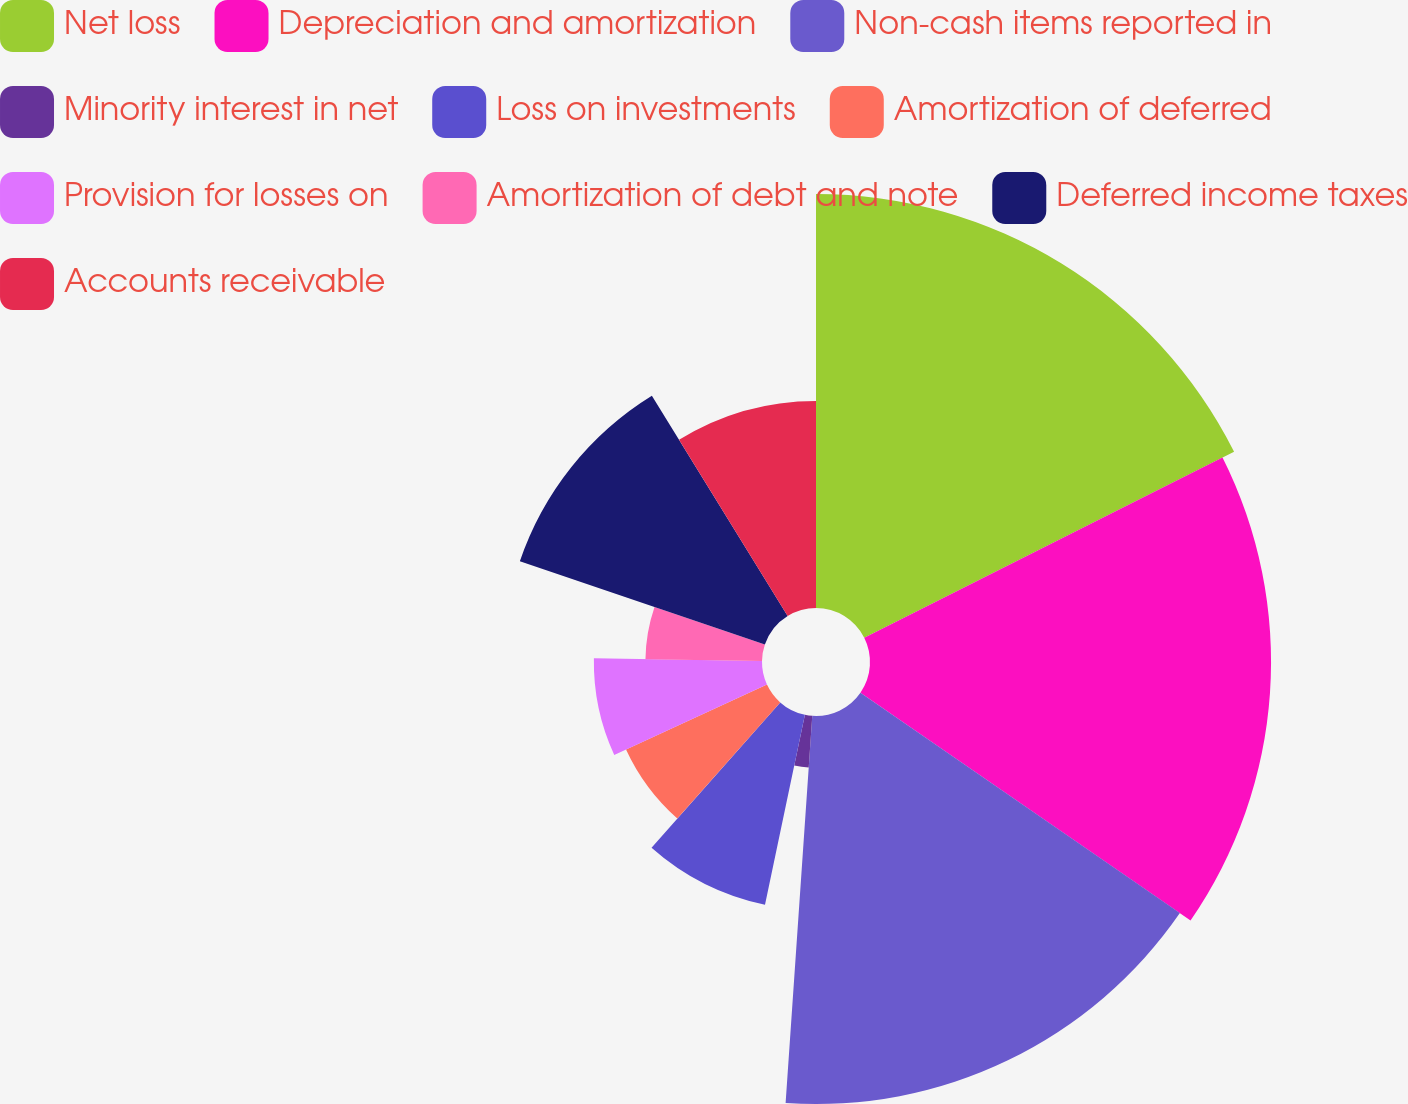Convert chart to OTSL. <chart><loc_0><loc_0><loc_500><loc_500><pie_chart><fcel>Net loss<fcel>Depreciation and amortization<fcel>Non-cash items reported in<fcel>Minority interest in net<fcel>Loss on investments<fcel>Amortization of deferred<fcel>Provision for losses on<fcel>Amortization of debt and note<fcel>Deferred income taxes<fcel>Accounts receivable<nl><fcel>17.58%<fcel>17.03%<fcel>16.48%<fcel>2.2%<fcel>8.24%<fcel>6.59%<fcel>7.14%<fcel>4.95%<fcel>10.99%<fcel>8.79%<nl></chart> 